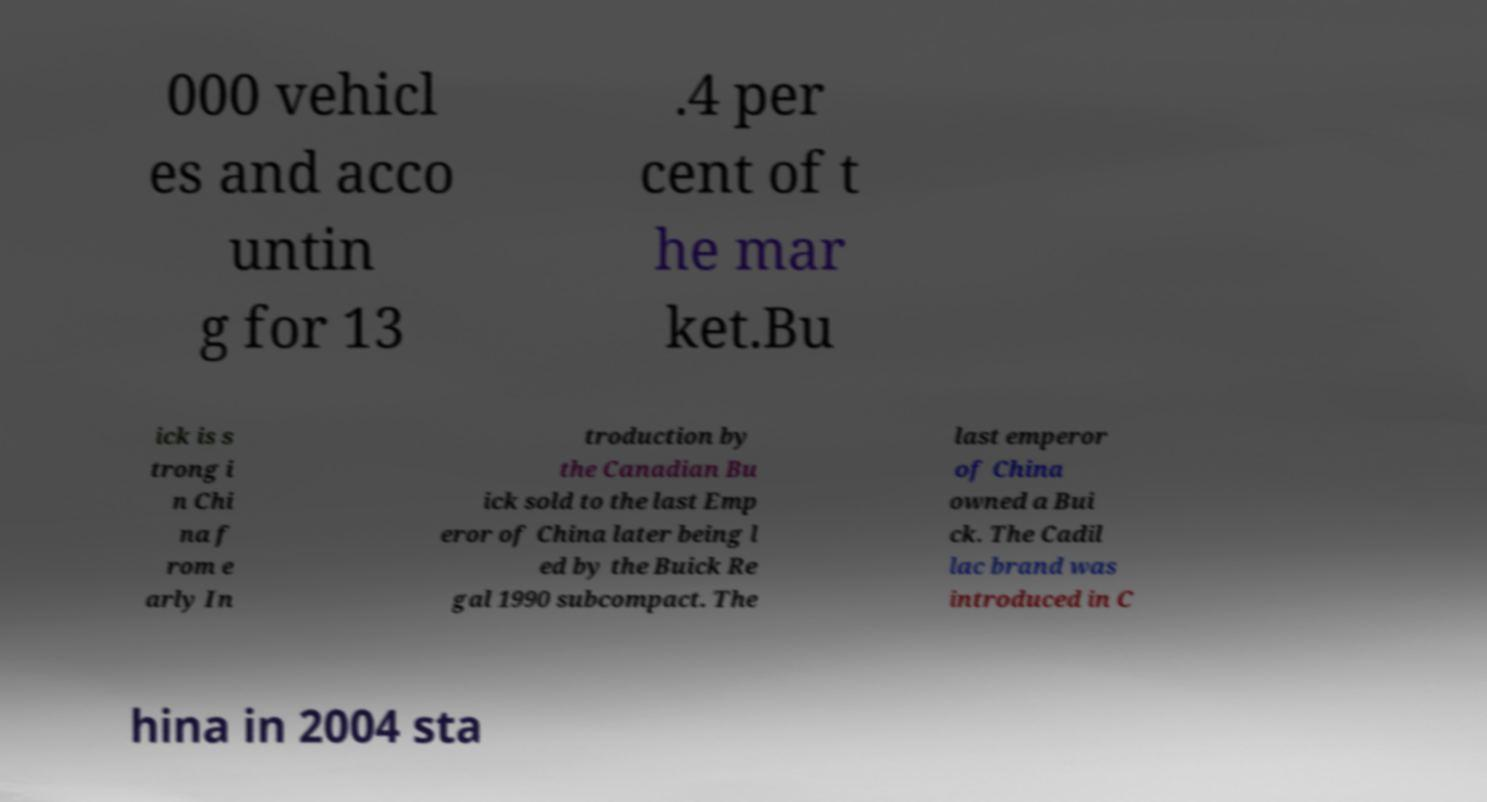What messages or text are displayed in this image? I need them in a readable, typed format. 000 vehicl es and acco untin g for 13 .4 per cent of t he mar ket.Bu ick is s trong i n Chi na f rom e arly In troduction by the Canadian Bu ick sold to the last Emp eror of China later being l ed by the Buick Re gal 1990 subcompact. The last emperor of China owned a Bui ck. The Cadil lac brand was introduced in C hina in 2004 sta 